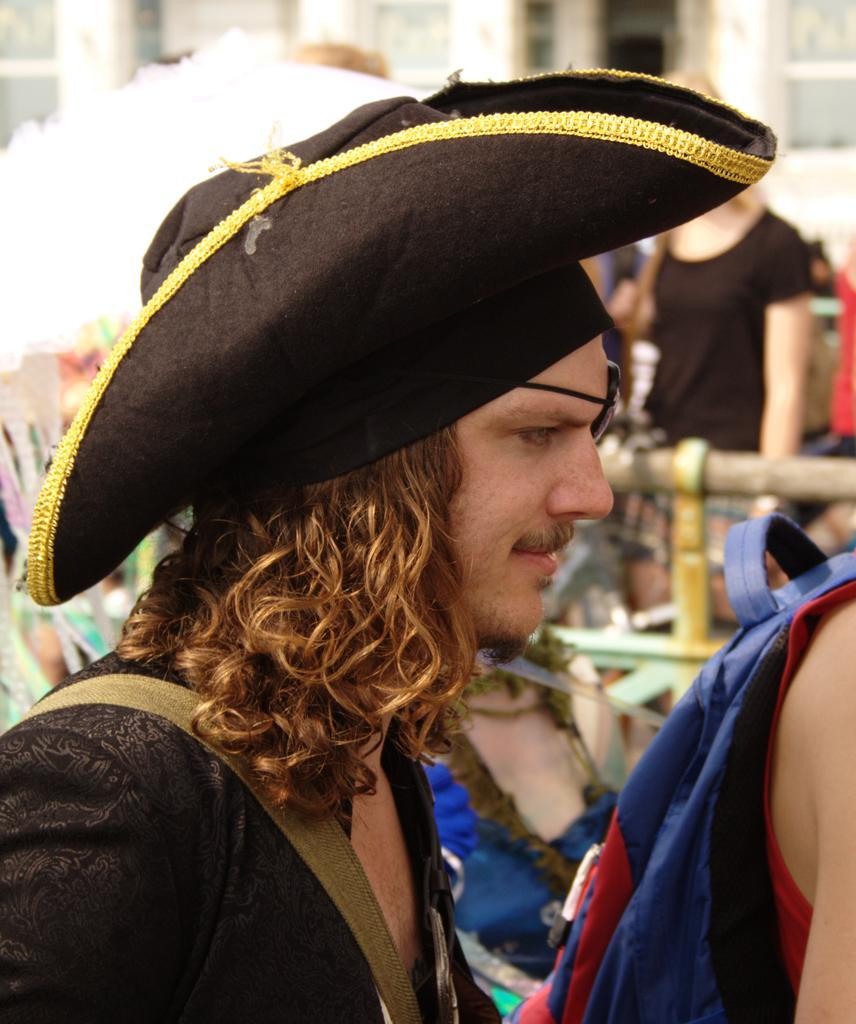What is the main subject of the image? The main subject of the image is a group of people. Can you describe the man in the middle of the group? The man in the middle of the group is wearing a cap. What can be seen in the background of the image? There are buildings in the background of the image. How many boys are sitting on the crate in the image? There is no crate or boys present in the image. What type of fire can be seen in the image? There is no fire present in the image. 